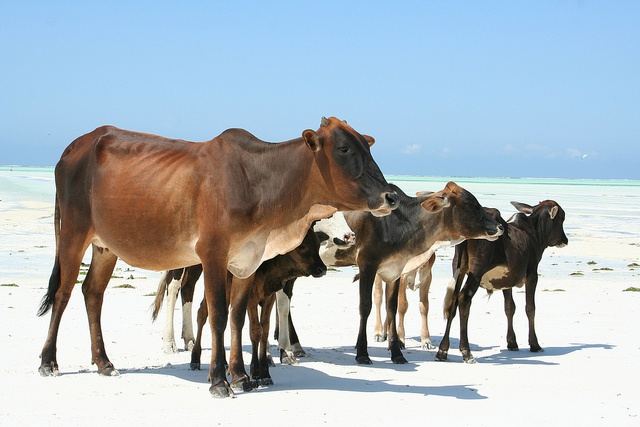Describe the objects in this image and their specific colors. I can see cow in lightblue, maroon, gray, and brown tones, cow in lightblue, black, gray, and maroon tones, cow in lightblue, black, and gray tones, cow in lightblue, black, maroon, and white tones, and cow in lightblue, ivory, black, darkgray, and gray tones in this image. 